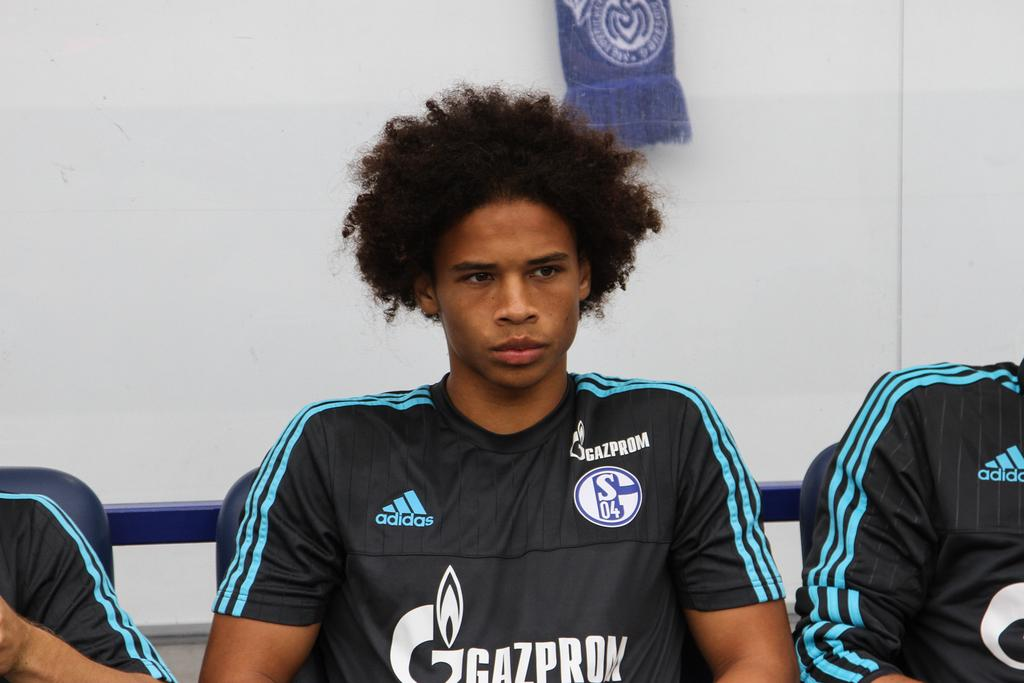<image>
Write a terse but informative summary of the picture. A player for Gazprom sits in a chair next to two other players. 